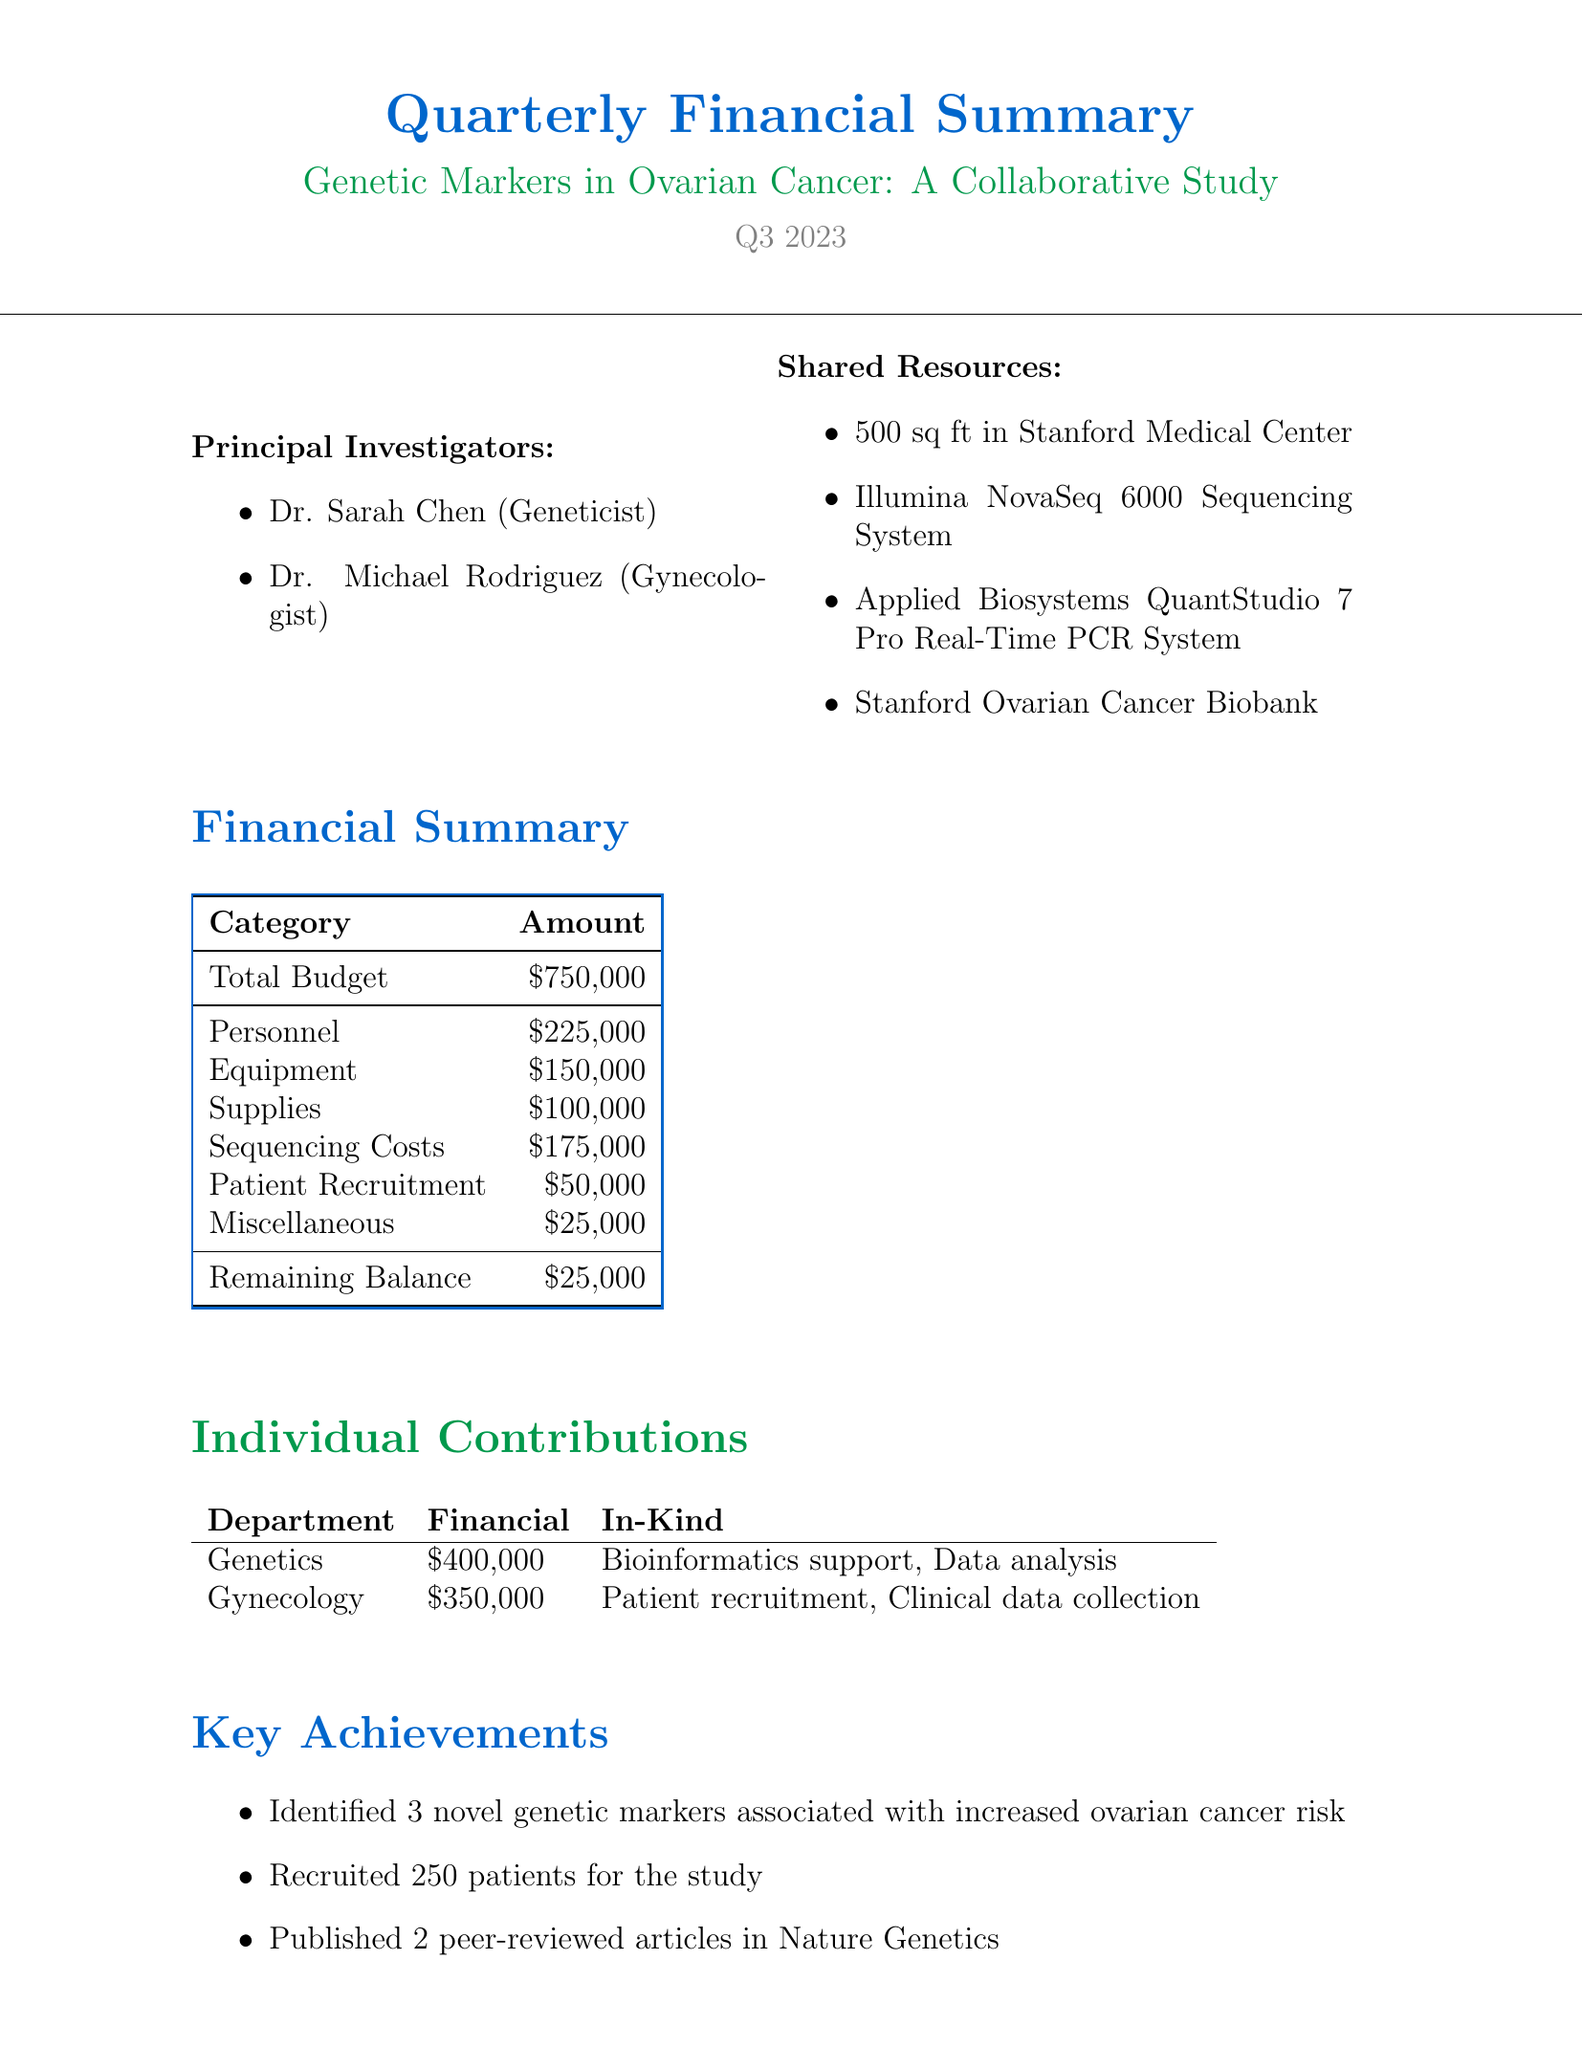What is the project title? The project title is explicitly stated at the beginning of the document.
Answer: Genetic Markers in Ovarian Cancer: A Collaborative Study Who are the principal investigators? The document lists the names and roles of the principal investigators.
Answer: Dr. Sarah Chen, Dr. Michael Rodriguez What is the total budget for the project? The total budget is a key budget-related figure mentioned in the financial summary.
Answer: $750,000 How much has the gynecology department contributed financially? The document specifies the financial contributions from each department in the individual contributions section.
Answer: $350,000 What is the remaining balance after expenses? The remaining balance is provided in the financial summary, indicating the funds left after accounting for expenses.
Answer: $25,000 How many patients were recruited for the study? The number of patients recruited is a key achievement highlighted in the document.
Answer: 250 patients What are the key achievements listed in the document? The document emphasizes significant accomplishments that have been achieved during the reporting period.
Answer: Identified 3 novel genetic markers associated with increased ovarian cancer risk What are the next quarter objectives? The upcoming goals are clearly outlined in the next quarter objectives section of the document.
Answer: Expand patient cohort to 500 What shared resource is specifically mentioned for the project? The document outlines the shared resources available for the project, including specific items.
Answer: 500 sq ft in Stanford Medical Center 